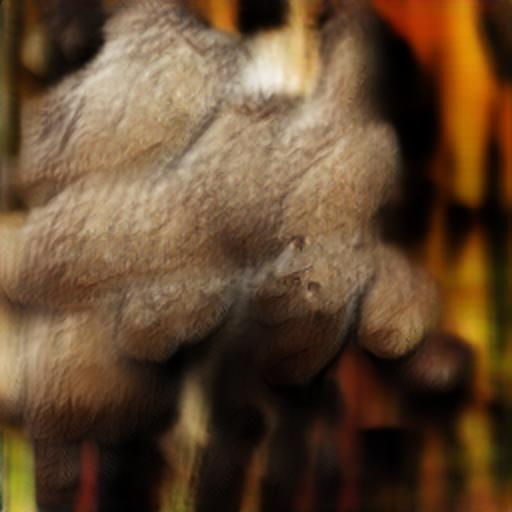What kind of adjustments might improve the clarity of this image? Increasing contrast, applying sharpening, and potentially adjusting the temperature of the image could help improve its clarity. If the blurring is intentional, these adjustments should be made carefully to maintain the artistic intent. 